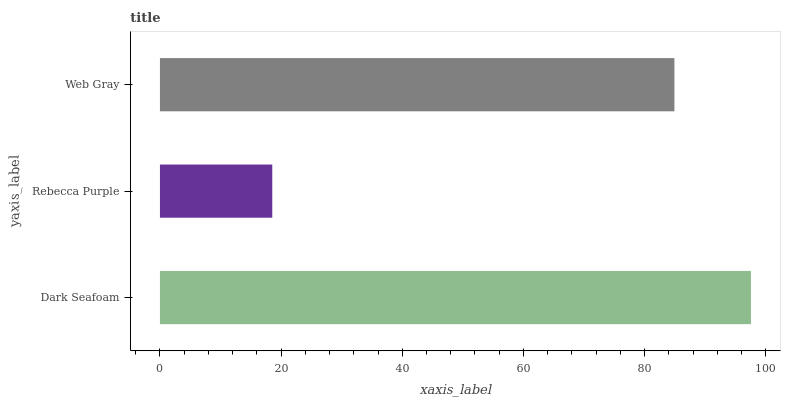Is Rebecca Purple the minimum?
Answer yes or no. Yes. Is Dark Seafoam the maximum?
Answer yes or no. Yes. Is Web Gray the minimum?
Answer yes or no. No. Is Web Gray the maximum?
Answer yes or no. No. Is Web Gray greater than Rebecca Purple?
Answer yes or no. Yes. Is Rebecca Purple less than Web Gray?
Answer yes or no. Yes. Is Rebecca Purple greater than Web Gray?
Answer yes or no. No. Is Web Gray less than Rebecca Purple?
Answer yes or no. No. Is Web Gray the high median?
Answer yes or no. Yes. Is Web Gray the low median?
Answer yes or no. Yes. Is Rebecca Purple the high median?
Answer yes or no. No. Is Rebecca Purple the low median?
Answer yes or no. No. 